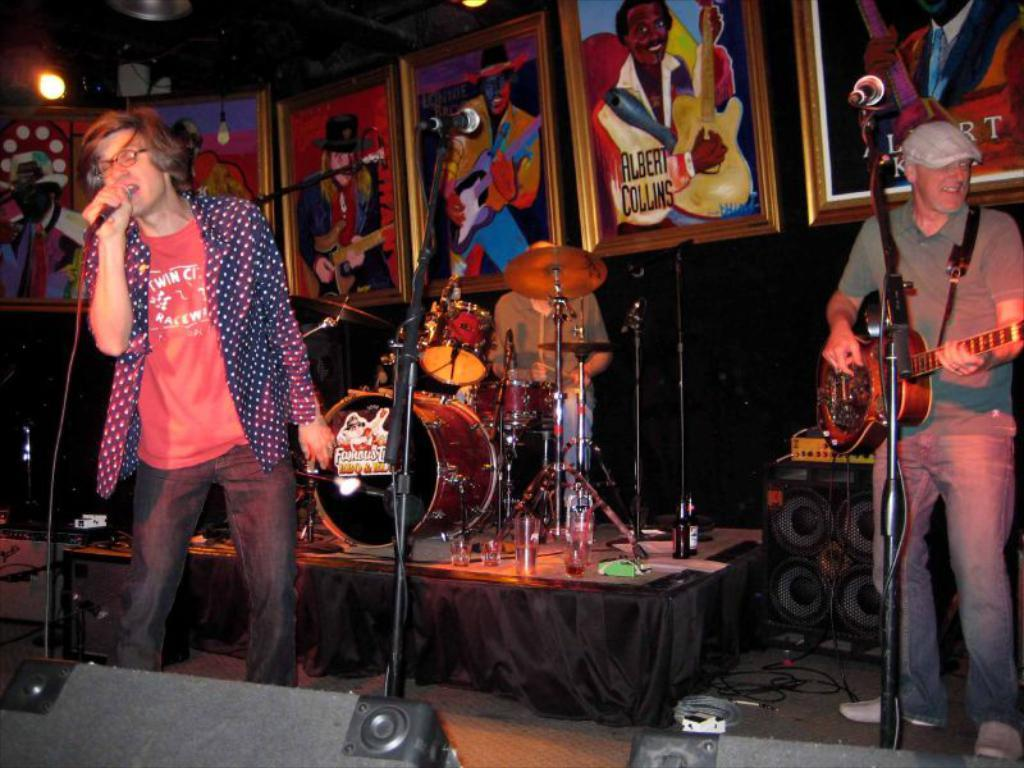How many people are in the image? There are two persons in the image. What is one person doing in the image? One person is playing a guitar. What is the other person doing in the image? The other person is singing into a microphone. What type of icicle can be seen hanging from the guitar in the image? There is no icicle present in the image, and the guitar is not hanging from anything. 